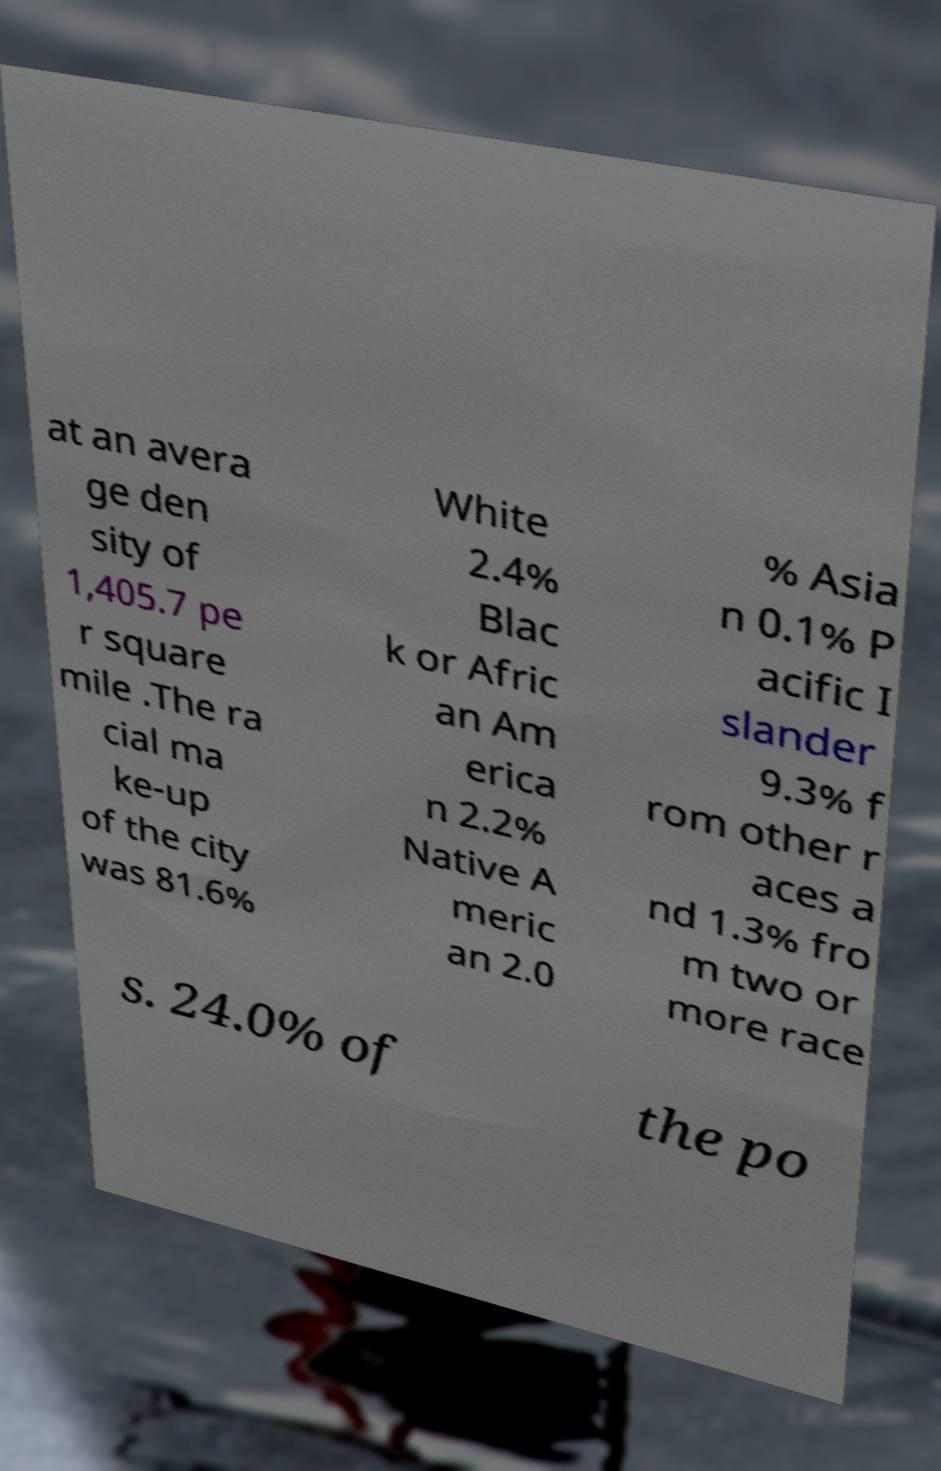For documentation purposes, I need the text within this image transcribed. Could you provide that? at an avera ge den sity of 1,405.7 pe r square mile .The ra cial ma ke-up of the city was 81.6% White 2.4% Blac k or Afric an Am erica n 2.2% Native A meric an 2.0 % Asia n 0.1% P acific I slander 9.3% f rom other r aces a nd 1.3% fro m two or more race s. 24.0% of the po 